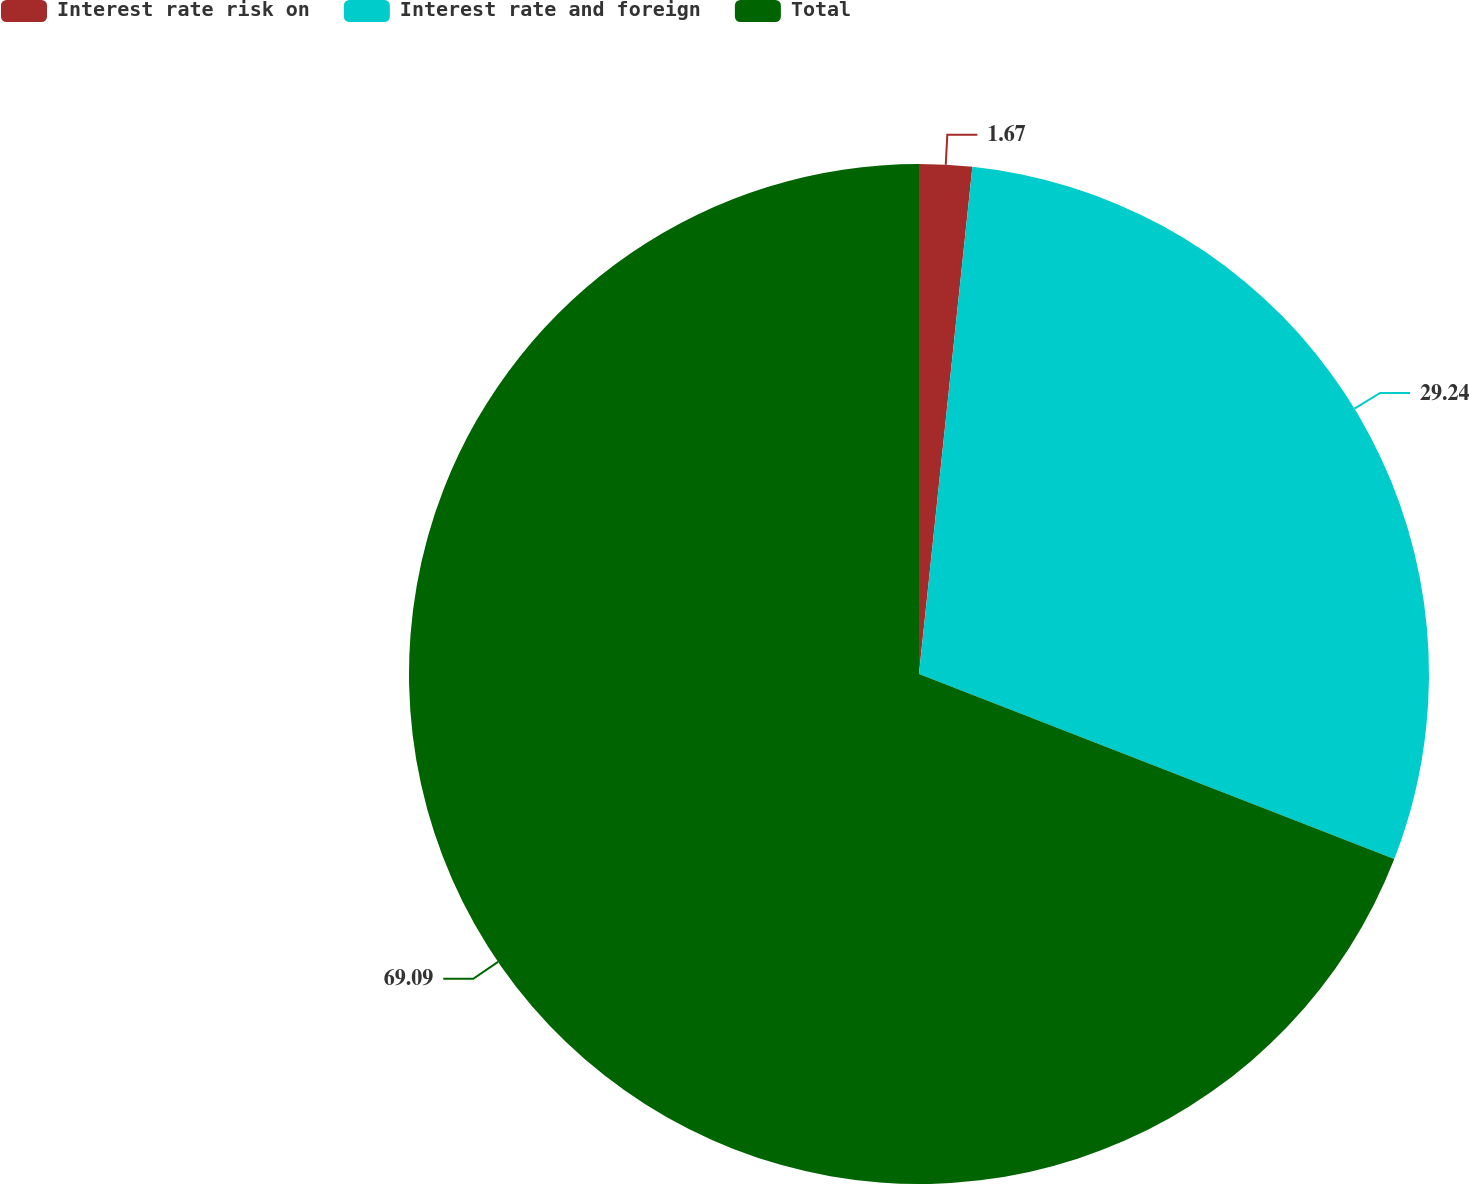Convert chart. <chart><loc_0><loc_0><loc_500><loc_500><pie_chart><fcel>Interest rate risk on<fcel>Interest rate and foreign<fcel>Total<nl><fcel>1.67%<fcel>29.24%<fcel>69.1%<nl></chart> 